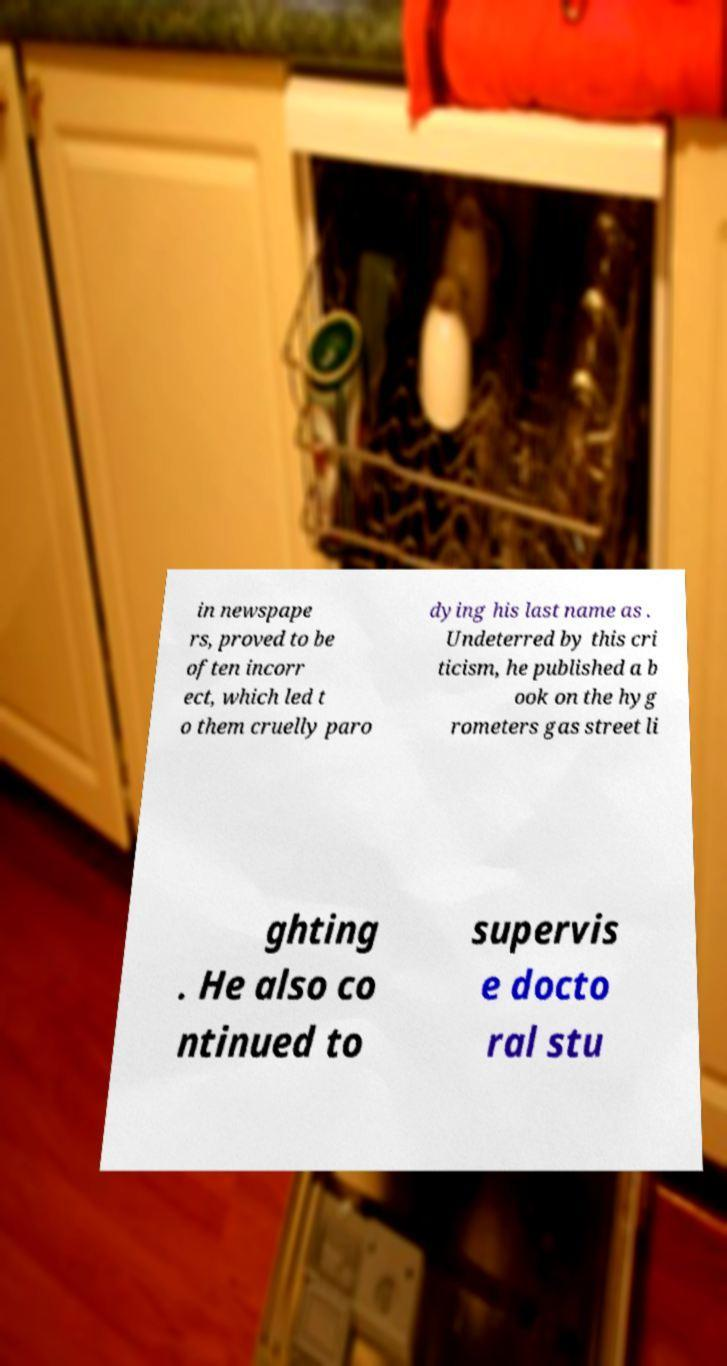I need the written content from this picture converted into text. Can you do that? in newspape rs, proved to be often incorr ect, which led t o them cruelly paro dying his last name as . Undeterred by this cri ticism, he published a b ook on the hyg rometers gas street li ghting . He also co ntinued to supervis e docto ral stu 